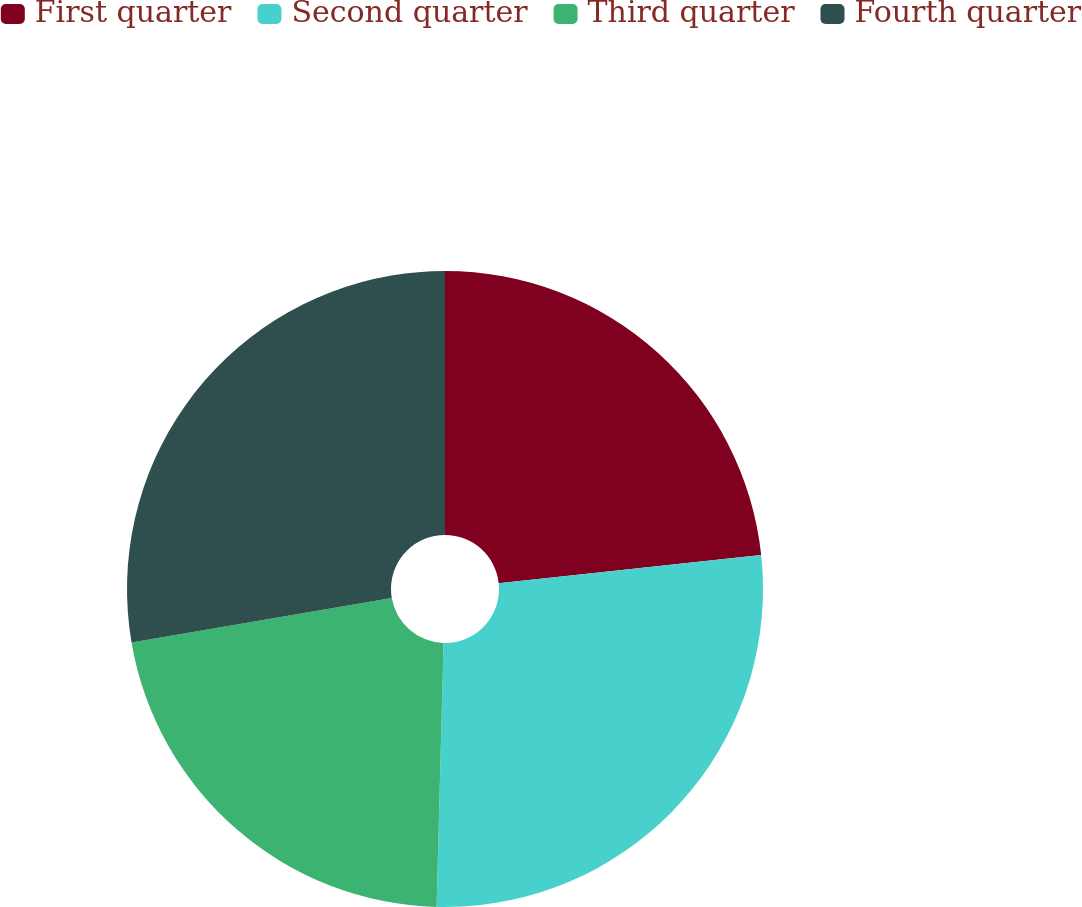Convert chart to OTSL. <chart><loc_0><loc_0><loc_500><loc_500><pie_chart><fcel>First quarter<fcel>Second quarter<fcel>Third quarter<fcel>Fourth quarter<nl><fcel>23.3%<fcel>27.12%<fcel>21.89%<fcel>27.69%<nl></chart> 